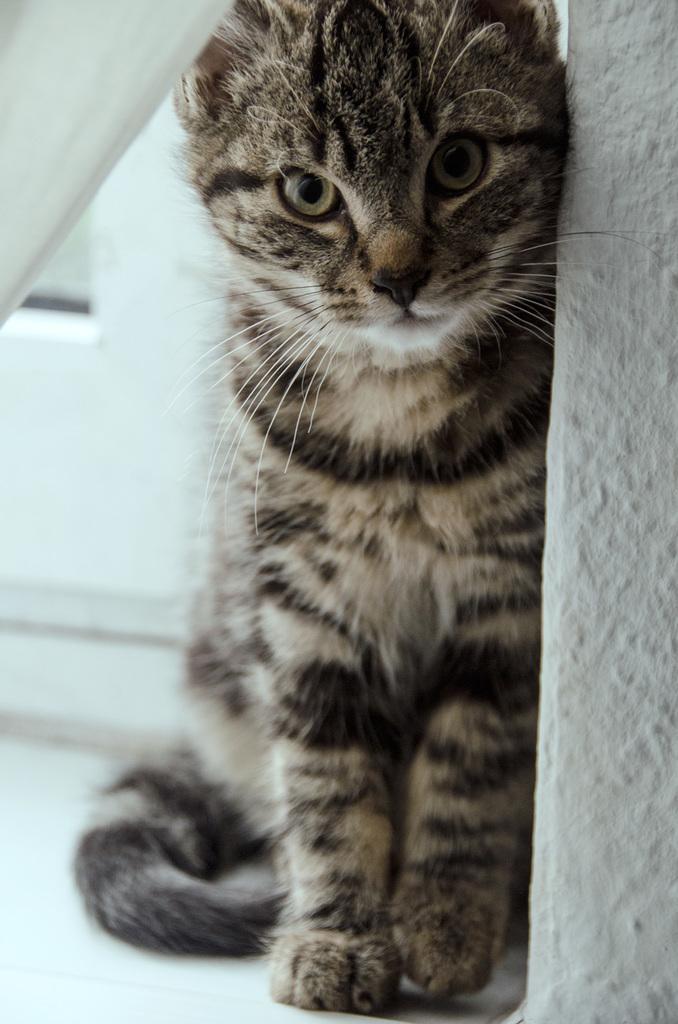In one or two sentences, can you explain what this image depicts? In this image I can see the white wall and I can see a cat which is of white and black color. 